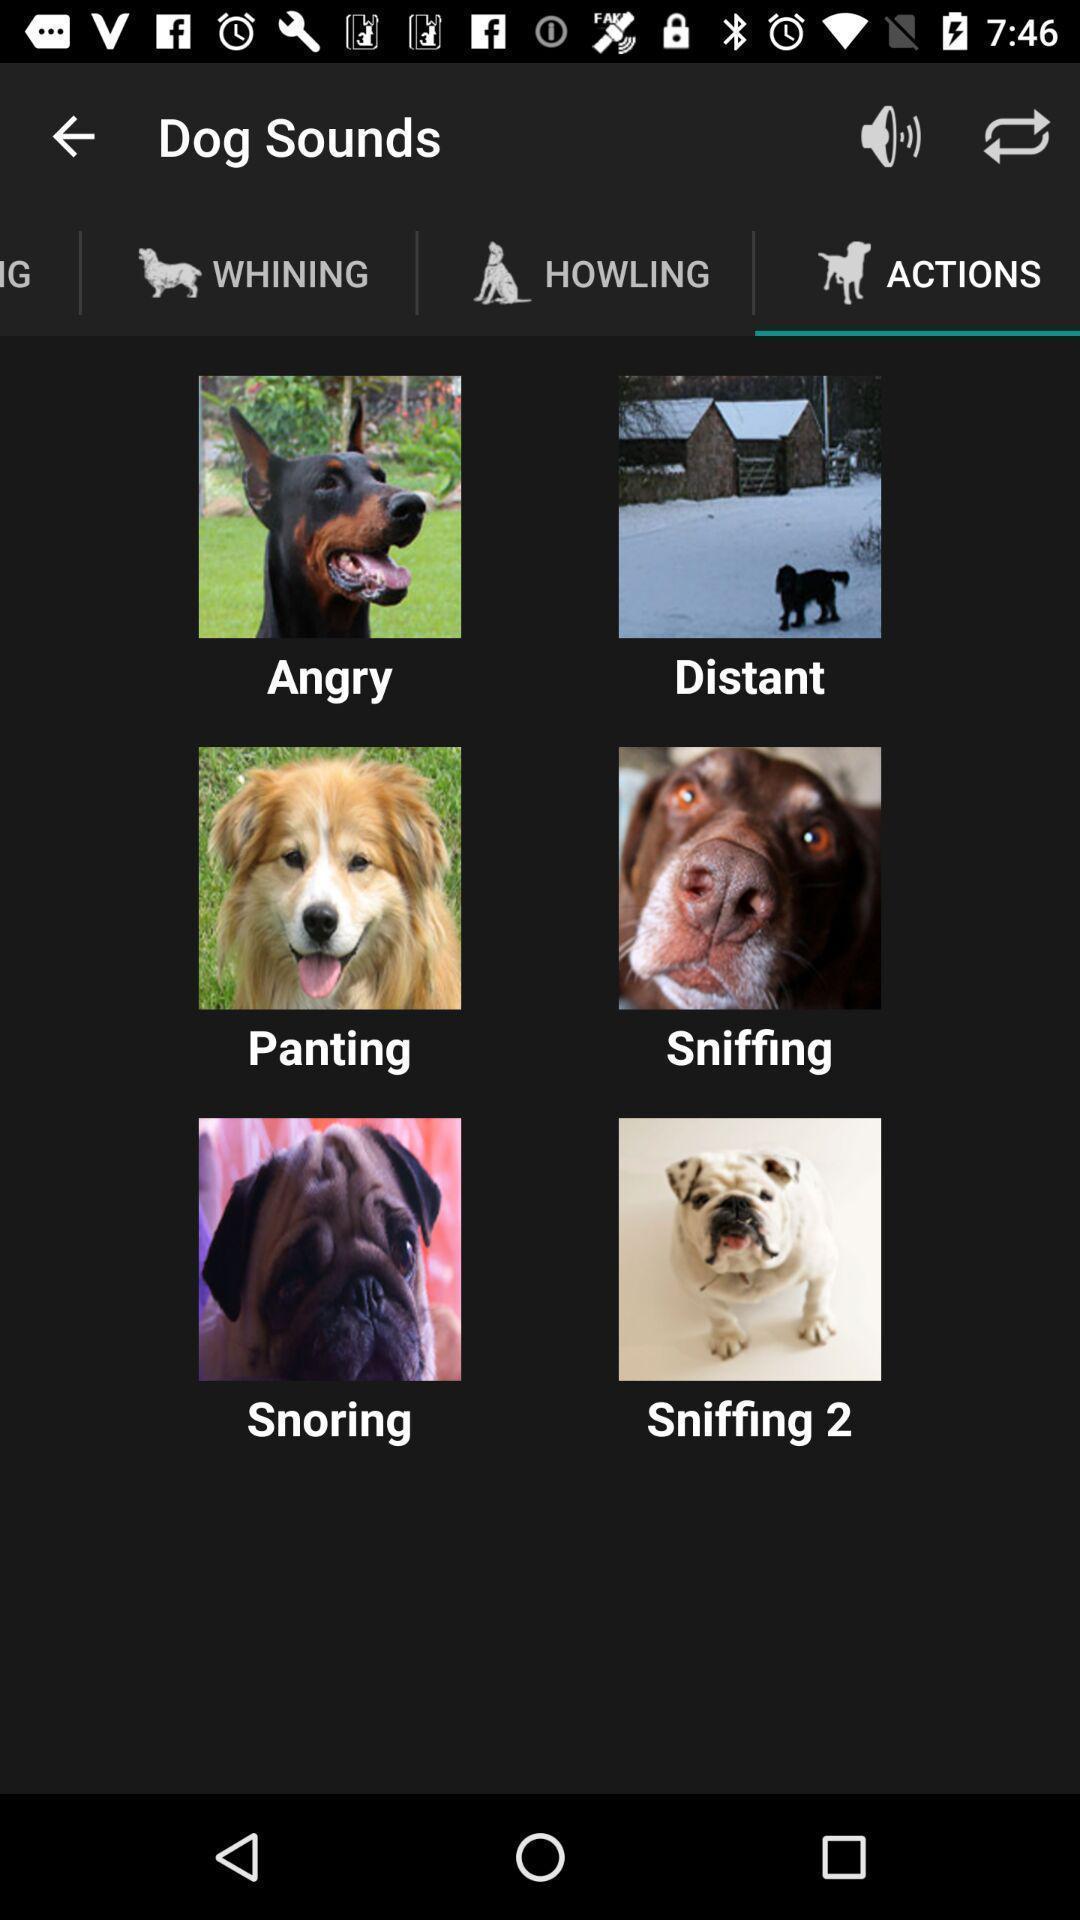Summarize the information in this screenshot. Page displays actions of dogs in app. 